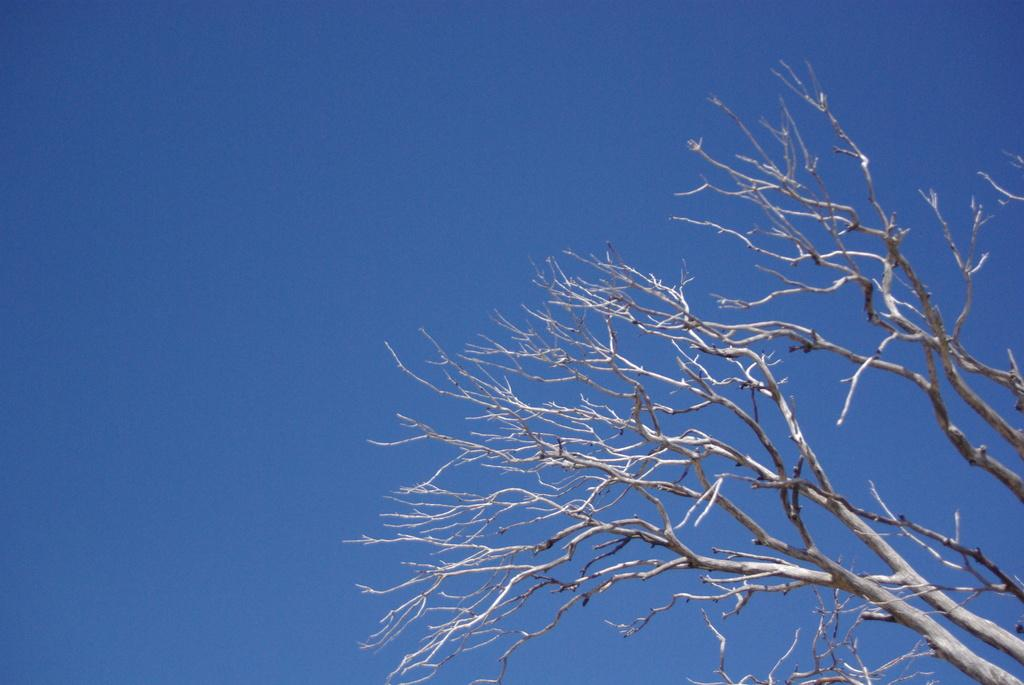What type of vegetation is present in the image? There are branches of a dry tree in the image. Can you describe the condition of the tree? The tree appears to be dry in the image. What month is depicted in the image? The image does not depict a specific month; it only shows branches of a dry tree. What type of jewelry is visible in the image? There is no jewelry present in the image; it only shows branches of a dry tree. 